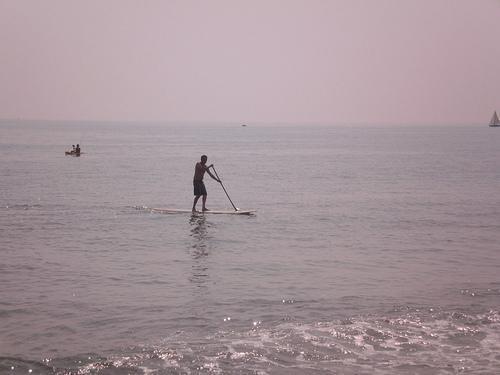How many people in the picture?
Give a very brief answer. 2. 